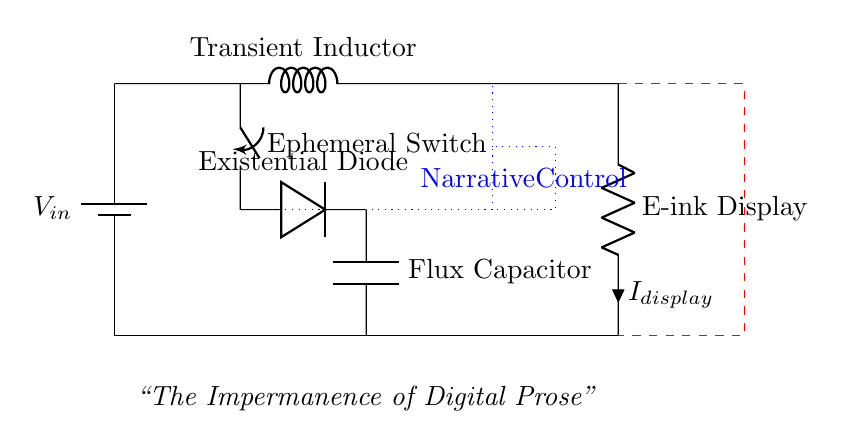What is the main power source in this circuit? The main power source is indicated by the battery symbol labeled V_in, located at the starting point of the circuit.
Answer: V_in What component is labeled as the "Existential Diode"? The Existential Diode is the component positioned between the Ephemeral Switch and the Flux Capacitor, which is a standard diode symbol.
Answer: Diode What is the purpose of the "Flux Capacitor"? The Flux Capacitor, labeled with its name and positioned below the Existential Diode, typically serves to store and release current in a controlled manner, especially for the E-ink display.
Answer: Capacitor How many components are part of the voltage sensing and feedback mechanism? There are one four-port device labeled as Voltage Feedback connected to the circuit layout, which indicates its role in providing control for voltage levels.
Answer: One What is the current flowing through the E-ink display labeled as? The current flowing through the E-ink display is labeled with i and denoted as I_display, suggesting it actively measures the current in that branch of the circuit.
Answer: I_display What is connected to the "Ephemeral Switch"? The Ephemeral Switch is connected to both the Transient Inductor and the Existential Diode, indicating its role in controlling the flow of current in those segments of the circuit.
Answer: Transient Inductor and Existential Diode What type of control unit is represented in the circuit? The control unit is labeled as "Narrative Control," which hints at its role in managing the overall operation and resource allocation in the power management circuit.
Answer: Narrative Control 